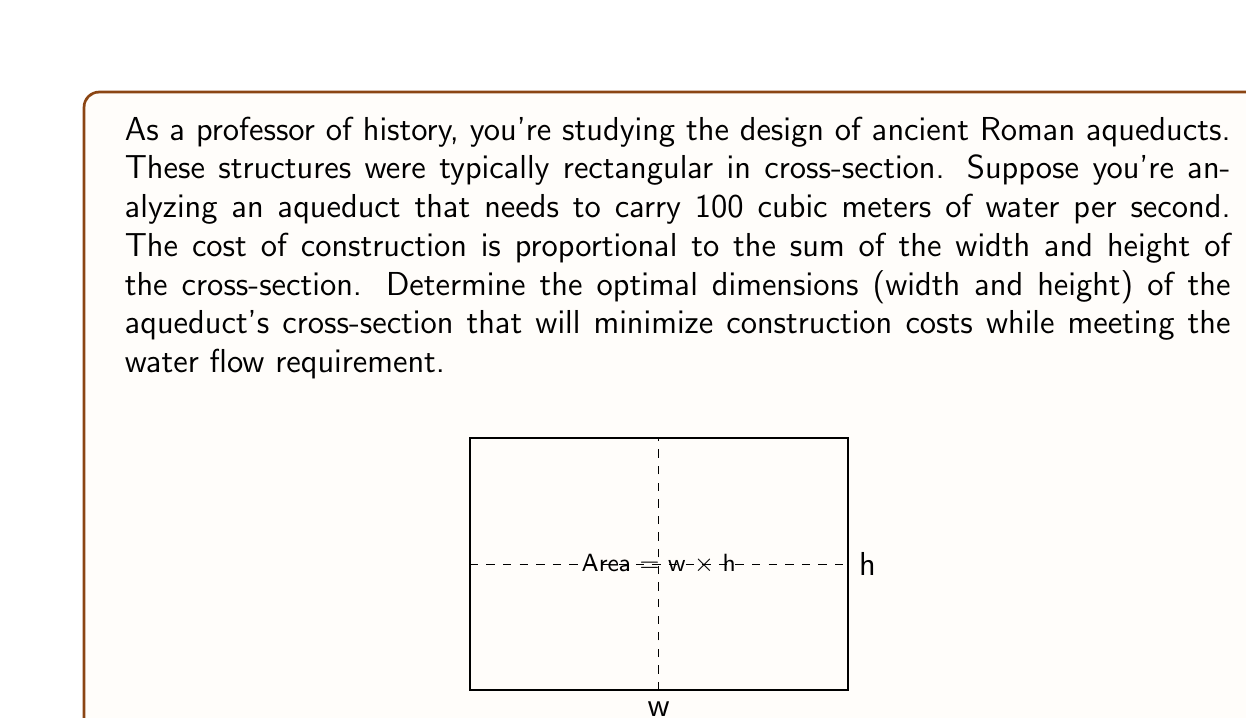Can you solve this math problem? Let's approach this step-by-step:

1) Let $w$ be the width and $h$ be the height of the aqueduct's cross-section.

2) The area of the cross-section must be such that it allows 100 cubic meters of water to flow per second. Assuming a constant flow velocity $v$, we can write:

   $$ A = \frac{100}{v} $$

   where $A$ is the area of the cross-section.

3) The area of the rectangular cross-section is given by:

   $$ A = wh = \frac{100}{v} $$

4) The cost is proportional to $(w + h)$. Our goal is to minimize this sum subject to the constraint $wh = \frac{100}{v}$.

5) We can use the method of Lagrange multipliers. Let's define:

   $$ f(w,h) = w + h $$
   $$ g(w,h) = wh - \frac{100}{v} $$

6) The Lagrange function is:

   $$ L(w,h,\lambda) = f(w,h) - \lambda g(w,h) = w + h - \lambda(wh - \frac{100}{v}) $$

7) Taking partial derivatives and setting them to zero:

   $$ \frac{\partial L}{\partial w} = 1 - \lambda h = 0 $$
   $$ \frac{\partial L}{\partial h} = 1 - \lambda w = 0 $$
   $$ \frac{\partial L}{\partial \lambda} = wh - \frac{100}{v} = 0 $$

8) From the first two equations, we can deduce that $w = h$.

9) Substituting this into the third equation:

   $$ w^2 = \frac{100}{v} $$

10) Therefore, the optimal dimensions are:

    $$ w = h = \sqrt{\frac{100}{v}} $$
Answer: $w = h = \sqrt{\frac{100}{v}}$, where $v$ is the flow velocity. 